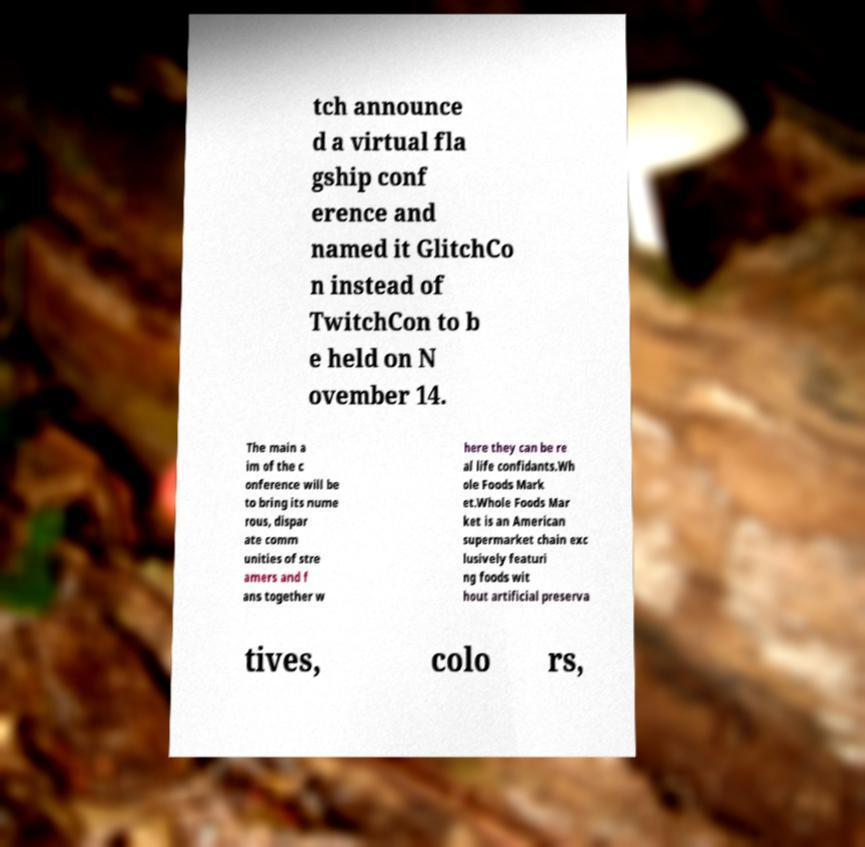Please identify and transcribe the text found in this image. tch announce d a virtual fla gship conf erence and named it GlitchCo n instead of TwitchCon to b e held on N ovember 14. The main a im of the c onference will be to bring its nume rous, dispar ate comm unities of stre amers and f ans together w here they can be re al life confidants.Wh ole Foods Mark et.Whole Foods Mar ket is an American supermarket chain exc lusively featuri ng foods wit hout artificial preserva tives, colo rs, 